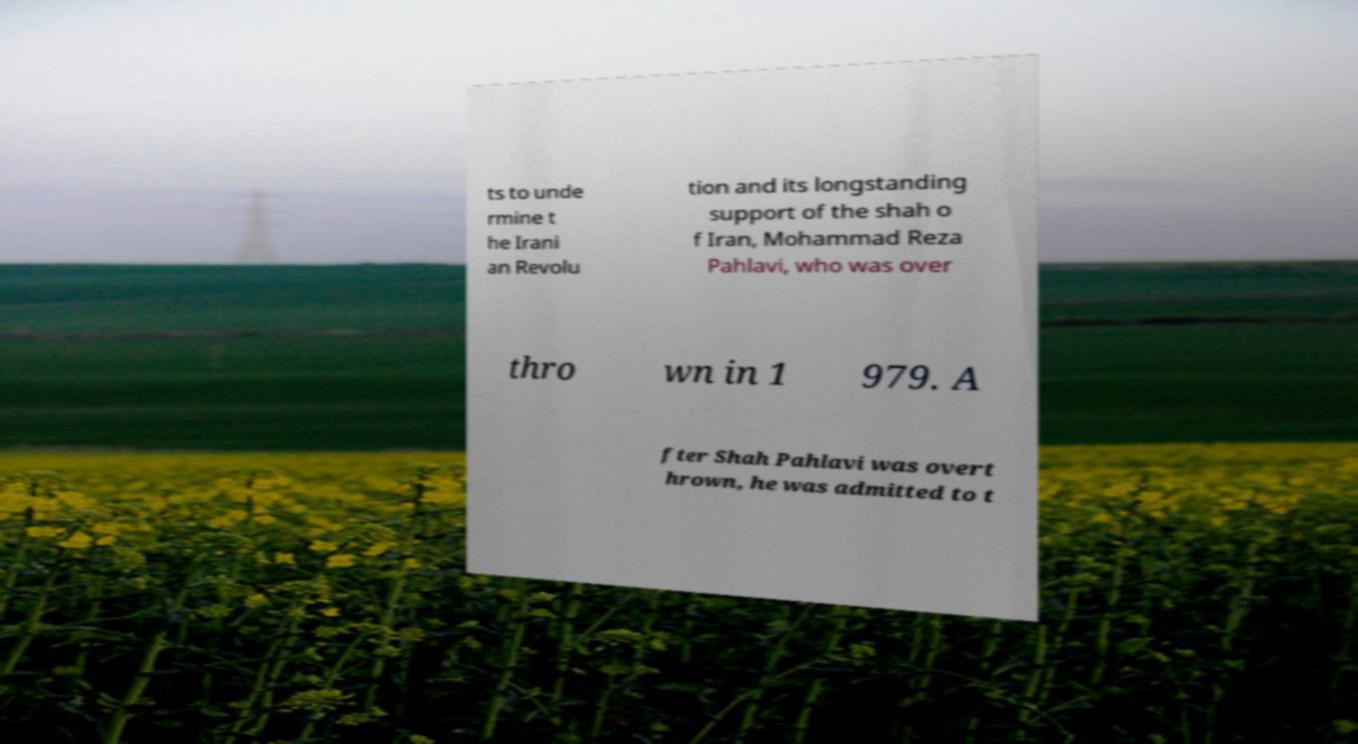Can you read and provide the text displayed in the image?This photo seems to have some interesting text. Can you extract and type it out for me? ts to unde rmine t he Irani an Revolu tion and its longstanding support of the shah o f Iran, Mohammad Reza Pahlavi, who was over thro wn in 1 979. A fter Shah Pahlavi was overt hrown, he was admitted to t 